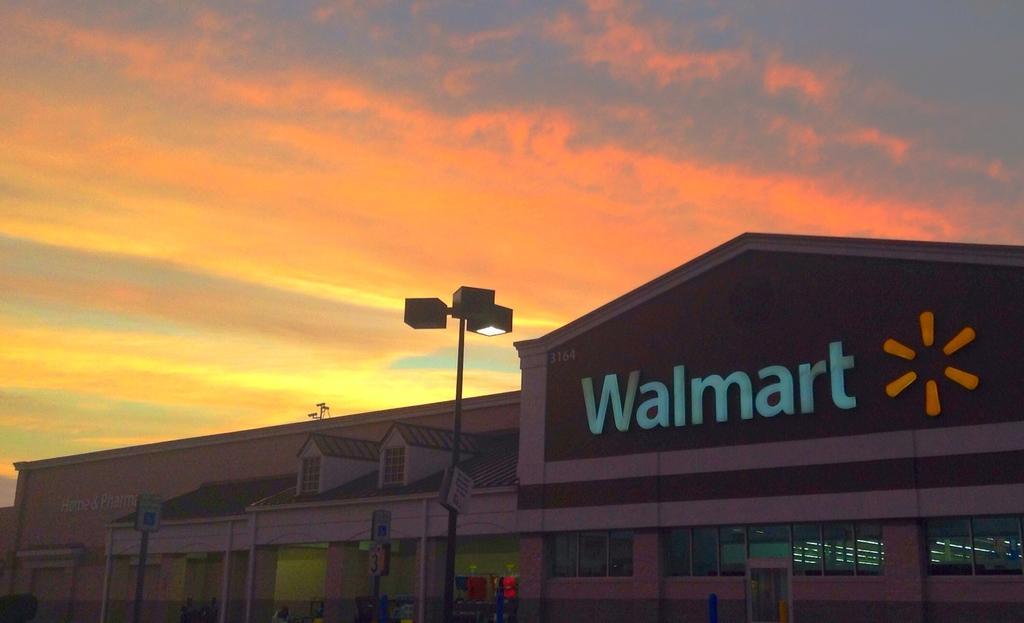How would you summarize this image in a sentence or two? At the bottom of the image there are few poles with lights. Also there is a building with walls, pillars and glass windows. At the top of the building there is a Walmart name. At the top of the image there is a sky. 